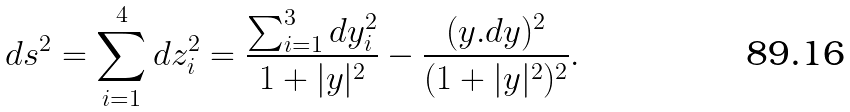Convert formula to latex. <formula><loc_0><loc_0><loc_500><loc_500>d s ^ { 2 } = \sum _ { i = 1 } ^ { 4 } d z _ { i } ^ { 2 } = \frac { \sum _ { i = 1 } ^ { 3 } d y _ { i } ^ { 2 } } { 1 + | y | ^ { 2 } } - \frac { ( y . d y ) ^ { 2 } } { ( 1 + | y | ^ { 2 } ) ^ { 2 } } .</formula> 